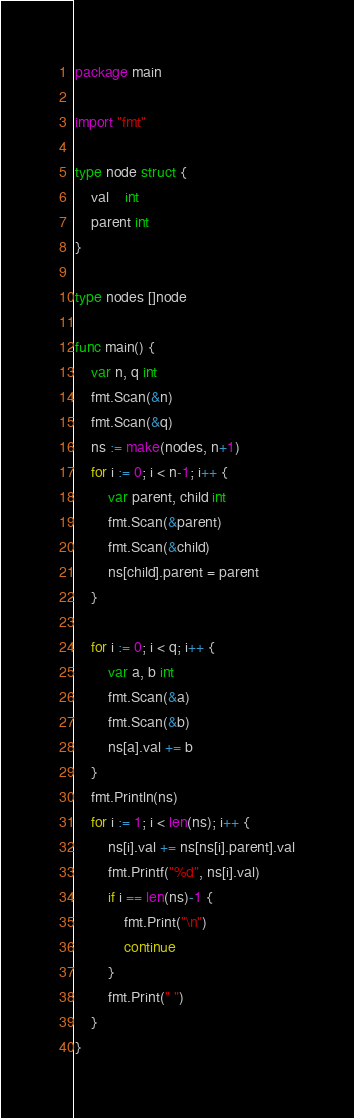Convert code to text. <code><loc_0><loc_0><loc_500><loc_500><_Go_>package main

import "fmt"

type node struct {
	val    int
	parent int
}

type nodes []node

func main() {
	var n, q int
	fmt.Scan(&n)
	fmt.Scan(&q)
	ns := make(nodes, n+1)
	for i := 0; i < n-1; i++ {
		var parent, child int
		fmt.Scan(&parent)
		fmt.Scan(&child)
		ns[child].parent = parent
	}

	for i := 0; i < q; i++ {
		var a, b int
		fmt.Scan(&a)
		fmt.Scan(&b)
		ns[a].val += b
	}
	fmt.Println(ns)
	for i := 1; i < len(ns); i++ {
		ns[i].val += ns[ns[i].parent].val
		fmt.Printf("%d", ns[i].val)
		if i == len(ns)-1 {
			fmt.Print("\n")
			continue
		}
		fmt.Print(" ")
	}
}
</code> 